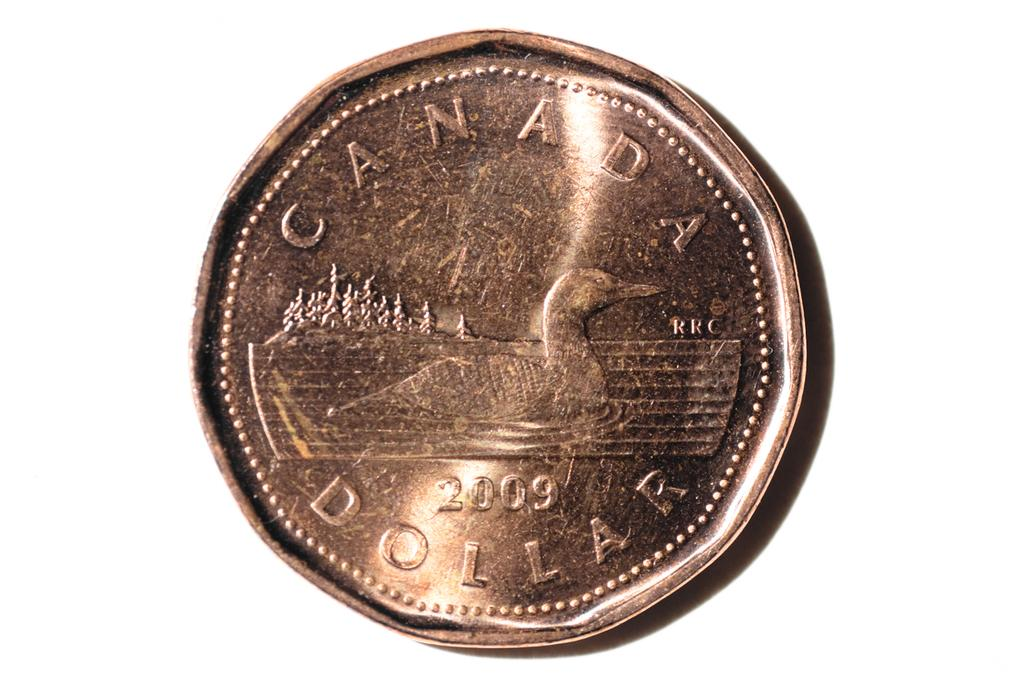<image>
Describe the image concisely. A shiny Canada Dollar printed in 2009 features a duck in a pond. 